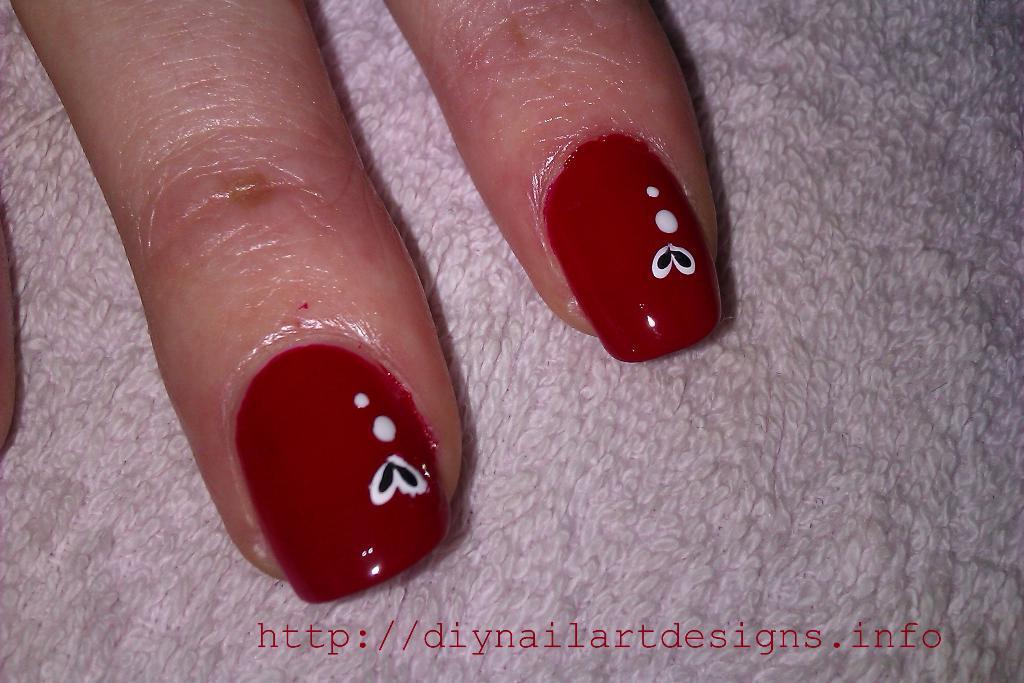How would you summarize this image in a sentence or two? This is a zoomed in picture. On the left there is a middle finger of a person. In the center we can see index finger of a person and we can see the red color nail polish with some nail art on the nails of both the fingers. In the foreground there is a white color object seems to be a cloth. At the bottom there is a watermark on the image. 